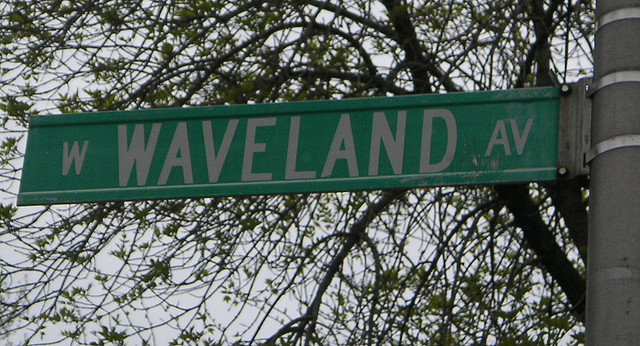Identify and read out the text in this image. W WAVELAND AV 